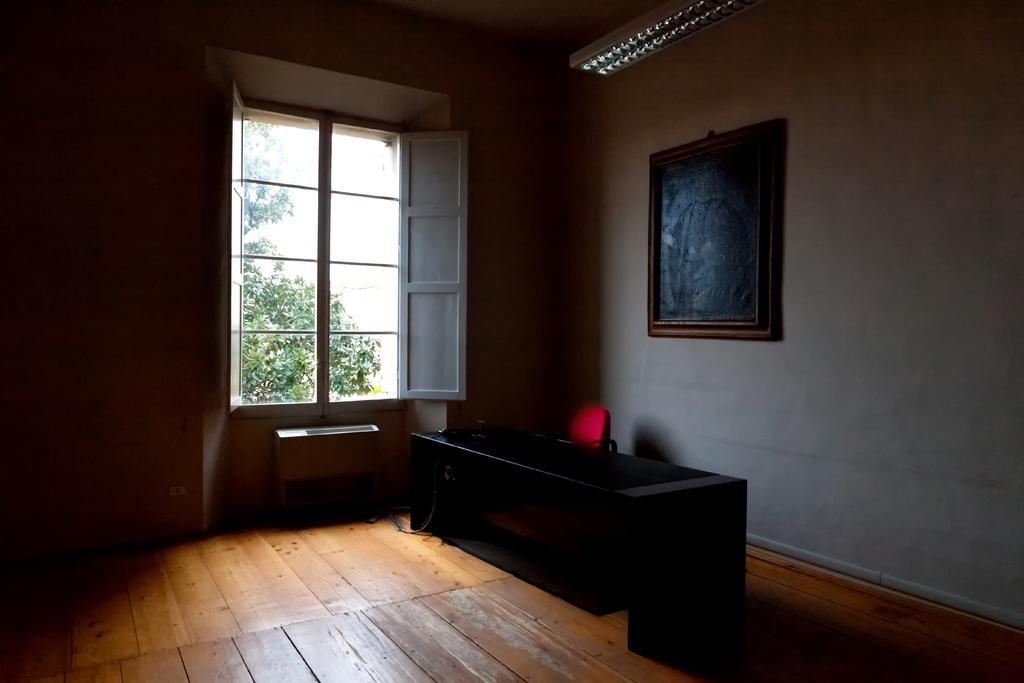What type of flooring is visible in the image? There is a wooden floor in the image. What piece of furniture can be seen in the image? There is a table in the image. What is present on the wall in the image? There is a frame in the image. What architectural feature is present in the image? There are walls in the image. What allows natural light to enter the room in the image? There is a window in the image. What provides illumination in the image? There are lights in the image. What can be found on the table in the image? There are objects in the image. What can be seen outside the window in the image? Branches and leaves are visible through the window. What type of statement is written on the apparel in the image? There is no apparel present in the image, so it is not possible to determine if any statements are written on it. 